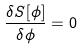<formula> <loc_0><loc_0><loc_500><loc_500>\frac { \delta S [ \phi ] } { \delta \phi } = 0</formula> 